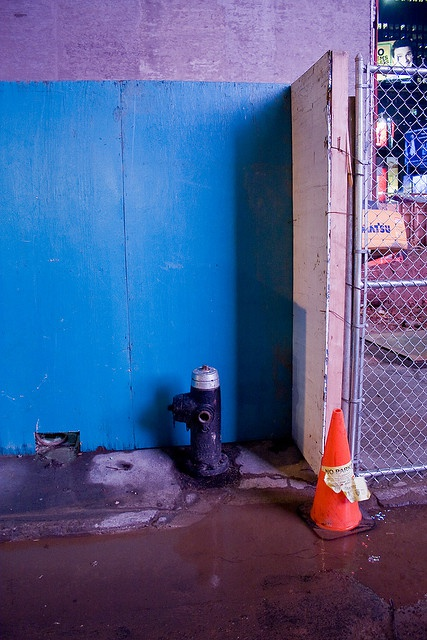Describe the objects in this image and their specific colors. I can see a fire hydrant in purple, black, and navy tones in this image. 